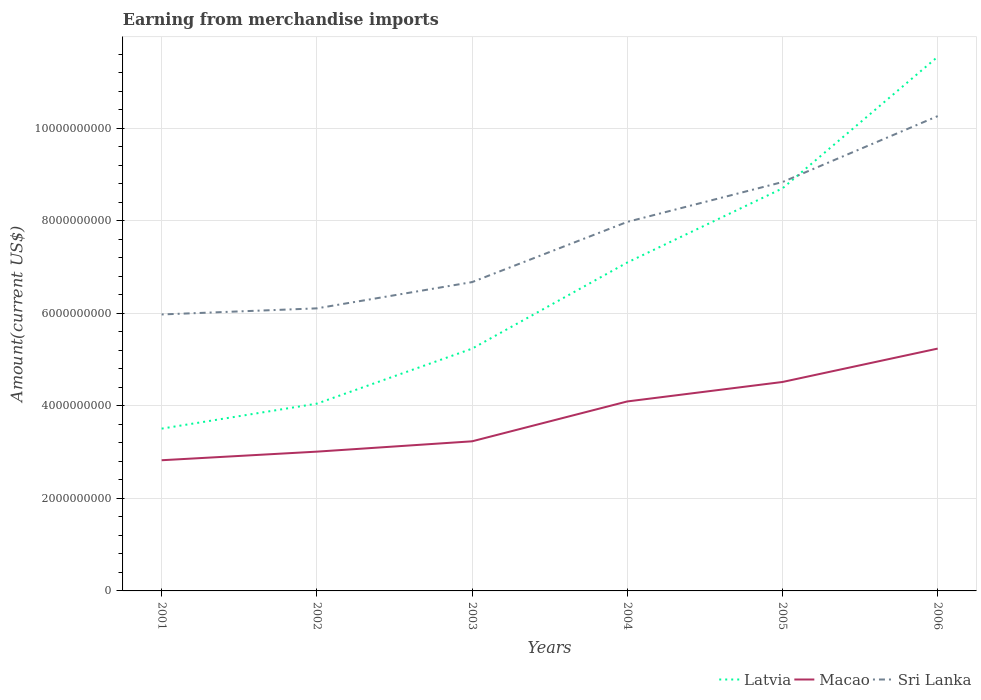Across all years, what is the maximum amount earned from merchandise imports in Sri Lanka?
Give a very brief answer. 5.97e+09. In which year was the amount earned from merchandise imports in Macao maximum?
Offer a terse response. 2001. What is the total amount earned from merchandise imports in Latvia in the graph?
Provide a short and direct response. -2.84e+09. What is the difference between the highest and the second highest amount earned from merchandise imports in Sri Lanka?
Offer a very short reply. 4.29e+09. What is the difference between two consecutive major ticks on the Y-axis?
Provide a short and direct response. 2.00e+09. Where does the legend appear in the graph?
Keep it short and to the point. Bottom right. What is the title of the graph?
Your answer should be very brief. Earning from merchandise imports. What is the label or title of the Y-axis?
Make the answer very short. Amount(current US$). What is the Amount(current US$) of Latvia in 2001?
Keep it short and to the point. 3.51e+09. What is the Amount(current US$) of Macao in 2001?
Offer a very short reply. 2.82e+09. What is the Amount(current US$) in Sri Lanka in 2001?
Ensure brevity in your answer.  5.97e+09. What is the Amount(current US$) of Latvia in 2002?
Offer a very short reply. 4.05e+09. What is the Amount(current US$) in Macao in 2002?
Your response must be concise. 3.01e+09. What is the Amount(current US$) of Sri Lanka in 2002?
Your answer should be compact. 6.10e+09. What is the Amount(current US$) in Latvia in 2003?
Provide a short and direct response. 5.23e+09. What is the Amount(current US$) in Macao in 2003?
Make the answer very short. 3.23e+09. What is the Amount(current US$) of Sri Lanka in 2003?
Your answer should be very brief. 6.67e+09. What is the Amount(current US$) in Latvia in 2004?
Offer a terse response. 7.10e+09. What is the Amount(current US$) of Macao in 2004?
Offer a terse response. 4.09e+09. What is the Amount(current US$) of Sri Lanka in 2004?
Provide a short and direct response. 7.97e+09. What is the Amount(current US$) of Latvia in 2005?
Your answer should be very brief. 8.70e+09. What is the Amount(current US$) in Macao in 2005?
Ensure brevity in your answer.  4.51e+09. What is the Amount(current US$) of Sri Lanka in 2005?
Your answer should be very brief. 8.83e+09. What is the Amount(current US$) in Latvia in 2006?
Your response must be concise. 1.15e+1. What is the Amount(current US$) of Macao in 2006?
Provide a short and direct response. 5.24e+09. What is the Amount(current US$) of Sri Lanka in 2006?
Keep it short and to the point. 1.03e+1. Across all years, what is the maximum Amount(current US$) in Latvia?
Your response must be concise. 1.15e+1. Across all years, what is the maximum Amount(current US$) of Macao?
Make the answer very short. 5.24e+09. Across all years, what is the maximum Amount(current US$) in Sri Lanka?
Your response must be concise. 1.03e+1. Across all years, what is the minimum Amount(current US$) of Latvia?
Provide a short and direct response. 3.51e+09. Across all years, what is the minimum Amount(current US$) of Macao?
Your response must be concise. 2.82e+09. Across all years, what is the minimum Amount(current US$) in Sri Lanka?
Your answer should be very brief. 5.97e+09. What is the total Amount(current US$) in Latvia in the graph?
Your response must be concise. 4.01e+1. What is the total Amount(current US$) in Macao in the graph?
Offer a terse response. 2.29e+1. What is the total Amount(current US$) in Sri Lanka in the graph?
Offer a very short reply. 4.58e+1. What is the difference between the Amount(current US$) of Latvia in 2001 and that in 2002?
Your answer should be compact. -5.40e+08. What is the difference between the Amount(current US$) in Macao in 2001 and that in 2002?
Give a very brief answer. -1.86e+08. What is the difference between the Amount(current US$) in Sri Lanka in 2001 and that in 2002?
Provide a short and direct response. -1.32e+08. What is the difference between the Amount(current US$) of Latvia in 2001 and that in 2003?
Provide a short and direct response. -1.73e+09. What is the difference between the Amount(current US$) of Macao in 2001 and that in 2003?
Your answer should be very brief. -4.09e+08. What is the difference between the Amount(current US$) in Sri Lanka in 2001 and that in 2003?
Offer a terse response. -6.99e+08. What is the difference between the Amount(current US$) of Latvia in 2001 and that in 2004?
Offer a very short reply. -3.59e+09. What is the difference between the Amount(current US$) in Macao in 2001 and that in 2004?
Your answer should be very brief. -1.27e+09. What is the difference between the Amount(current US$) of Sri Lanka in 2001 and that in 2004?
Provide a short and direct response. -2.00e+09. What is the difference between the Amount(current US$) of Latvia in 2001 and that in 2005?
Your answer should be compact. -5.19e+09. What is the difference between the Amount(current US$) in Macao in 2001 and that in 2005?
Give a very brief answer. -1.69e+09. What is the difference between the Amount(current US$) of Sri Lanka in 2001 and that in 2005?
Your answer should be very brief. -2.86e+09. What is the difference between the Amount(current US$) in Latvia in 2001 and that in 2006?
Your response must be concise. -8.03e+09. What is the difference between the Amount(current US$) in Macao in 2001 and that in 2006?
Your response must be concise. -2.41e+09. What is the difference between the Amount(current US$) of Sri Lanka in 2001 and that in 2006?
Make the answer very short. -4.29e+09. What is the difference between the Amount(current US$) in Latvia in 2002 and that in 2003?
Give a very brief answer. -1.19e+09. What is the difference between the Amount(current US$) in Macao in 2002 and that in 2003?
Your response must be concise. -2.23e+08. What is the difference between the Amount(current US$) in Sri Lanka in 2002 and that in 2003?
Your answer should be very brief. -5.67e+08. What is the difference between the Amount(current US$) of Latvia in 2002 and that in 2004?
Provide a succinct answer. -3.05e+09. What is the difference between the Amount(current US$) in Macao in 2002 and that in 2004?
Offer a very short reply. -1.08e+09. What is the difference between the Amount(current US$) of Sri Lanka in 2002 and that in 2004?
Offer a very short reply. -1.87e+09. What is the difference between the Amount(current US$) in Latvia in 2002 and that in 2005?
Your response must be concise. -4.65e+09. What is the difference between the Amount(current US$) of Macao in 2002 and that in 2005?
Offer a terse response. -1.51e+09. What is the difference between the Amount(current US$) in Sri Lanka in 2002 and that in 2005?
Ensure brevity in your answer.  -2.73e+09. What is the difference between the Amount(current US$) in Latvia in 2002 and that in 2006?
Offer a terse response. -7.49e+09. What is the difference between the Amount(current US$) in Macao in 2002 and that in 2006?
Offer a terse response. -2.23e+09. What is the difference between the Amount(current US$) of Sri Lanka in 2002 and that in 2006?
Offer a very short reply. -4.15e+09. What is the difference between the Amount(current US$) in Latvia in 2003 and that in 2004?
Provide a short and direct response. -1.86e+09. What is the difference between the Amount(current US$) in Macao in 2003 and that in 2004?
Make the answer very short. -8.61e+08. What is the difference between the Amount(current US$) of Sri Lanka in 2003 and that in 2004?
Your response must be concise. -1.30e+09. What is the difference between the Amount(current US$) in Latvia in 2003 and that in 2005?
Ensure brevity in your answer.  -3.46e+09. What is the difference between the Amount(current US$) of Macao in 2003 and that in 2005?
Your response must be concise. -1.28e+09. What is the difference between the Amount(current US$) in Sri Lanka in 2003 and that in 2005?
Provide a short and direct response. -2.16e+09. What is the difference between the Amount(current US$) of Latvia in 2003 and that in 2006?
Keep it short and to the point. -6.31e+09. What is the difference between the Amount(current US$) in Macao in 2003 and that in 2006?
Your response must be concise. -2.00e+09. What is the difference between the Amount(current US$) of Sri Lanka in 2003 and that in 2006?
Your answer should be very brief. -3.59e+09. What is the difference between the Amount(current US$) in Latvia in 2004 and that in 2005?
Your response must be concise. -1.60e+09. What is the difference between the Amount(current US$) of Macao in 2004 and that in 2005?
Offer a terse response. -4.21e+08. What is the difference between the Amount(current US$) in Sri Lanka in 2004 and that in 2005?
Make the answer very short. -8.61e+08. What is the difference between the Amount(current US$) of Latvia in 2004 and that in 2006?
Give a very brief answer. -4.45e+09. What is the difference between the Amount(current US$) of Macao in 2004 and that in 2006?
Your response must be concise. -1.14e+09. What is the difference between the Amount(current US$) in Sri Lanka in 2004 and that in 2006?
Make the answer very short. -2.29e+09. What is the difference between the Amount(current US$) of Latvia in 2005 and that in 2006?
Give a very brief answer. -2.84e+09. What is the difference between the Amount(current US$) in Macao in 2005 and that in 2006?
Provide a short and direct response. -7.21e+08. What is the difference between the Amount(current US$) in Sri Lanka in 2005 and that in 2006?
Provide a short and direct response. -1.42e+09. What is the difference between the Amount(current US$) of Latvia in 2001 and the Amount(current US$) of Macao in 2002?
Make the answer very short. 4.97e+08. What is the difference between the Amount(current US$) in Latvia in 2001 and the Amount(current US$) in Sri Lanka in 2002?
Offer a terse response. -2.60e+09. What is the difference between the Amount(current US$) in Macao in 2001 and the Amount(current US$) in Sri Lanka in 2002?
Your answer should be very brief. -3.28e+09. What is the difference between the Amount(current US$) in Latvia in 2001 and the Amount(current US$) in Macao in 2003?
Your response must be concise. 2.74e+08. What is the difference between the Amount(current US$) in Latvia in 2001 and the Amount(current US$) in Sri Lanka in 2003?
Provide a short and direct response. -3.17e+09. What is the difference between the Amount(current US$) of Macao in 2001 and the Amount(current US$) of Sri Lanka in 2003?
Keep it short and to the point. -3.85e+09. What is the difference between the Amount(current US$) of Latvia in 2001 and the Amount(current US$) of Macao in 2004?
Give a very brief answer. -5.88e+08. What is the difference between the Amount(current US$) of Latvia in 2001 and the Amount(current US$) of Sri Lanka in 2004?
Provide a short and direct response. -4.47e+09. What is the difference between the Amount(current US$) in Macao in 2001 and the Amount(current US$) in Sri Lanka in 2004?
Keep it short and to the point. -5.15e+09. What is the difference between the Amount(current US$) in Latvia in 2001 and the Amount(current US$) in Macao in 2005?
Your answer should be compact. -1.01e+09. What is the difference between the Amount(current US$) in Latvia in 2001 and the Amount(current US$) in Sri Lanka in 2005?
Your answer should be compact. -5.33e+09. What is the difference between the Amount(current US$) in Macao in 2001 and the Amount(current US$) in Sri Lanka in 2005?
Give a very brief answer. -6.01e+09. What is the difference between the Amount(current US$) in Latvia in 2001 and the Amount(current US$) in Macao in 2006?
Your response must be concise. -1.73e+09. What is the difference between the Amount(current US$) of Latvia in 2001 and the Amount(current US$) of Sri Lanka in 2006?
Your response must be concise. -6.75e+09. What is the difference between the Amount(current US$) in Macao in 2001 and the Amount(current US$) in Sri Lanka in 2006?
Provide a short and direct response. -7.43e+09. What is the difference between the Amount(current US$) of Latvia in 2002 and the Amount(current US$) of Macao in 2003?
Your answer should be very brief. 8.14e+08. What is the difference between the Amount(current US$) of Latvia in 2002 and the Amount(current US$) of Sri Lanka in 2003?
Your answer should be compact. -2.63e+09. What is the difference between the Amount(current US$) in Macao in 2002 and the Amount(current US$) in Sri Lanka in 2003?
Keep it short and to the point. -3.66e+09. What is the difference between the Amount(current US$) in Latvia in 2002 and the Amount(current US$) in Macao in 2004?
Offer a terse response. -4.77e+07. What is the difference between the Amount(current US$) in Latvia in 2002 and the Amount(current US$) in Sri Lanka in 2004?
Your response must be concise. -3.93e+09. What is the difference between the Amount(current US$) of Macao in 2002 and the Amount(current US$) of Sri Lanka in 2004?
Offer a terse response. -4.96e+09. What is the difference between the Amount(current US$) in Latvia in 2002 and the Amount(current US$) in Macao in 2005?
Offer a terse response. -4.68e+08. What is the difference between the Amount(current US$) in Latvia in 2002 and the Amount(current US$) in Sri Lanka in 2005?
Make the answer very short. -4.79e+09. What is the difference between the Amount(current US$) in Macao in 2002 and the Amount(current US$) in Sri Lanka in 2005?
Your answer should be compact. -5.82e+09. What is the difference between the Amount(current US$) in Latvia in 2002 and the Amount(current US$) in Macao in 2006?
Your answer should be compact. -1.19e+09. What is the difference between the Amount(current US$) of Latvia in 2002 and the Amount(current US$) of Sri Lanka in 2006?
Make the answer very short. -6.21e+09. What is the difference between the Amount(current US$) of Macao in 2002 and the Amount(current US$) of Sri Lanka in 2006?
Offer a terse response. -7.25e+09. What is the difference between the Amount(current US$) in Latvia in 2003 and the Amount(current US$) in Macao in 2004?
Provide a succinct answer. 1.14e+09. What is the difference between the Amount(current US$) of Latvia in 2003 and the Amount(current US$) of Sri Lanka in 2004?
Ensure brevity in your answer.  -2.74e+09. What is the difference between the Amount(current US$) of Macao in 2003 and the Amount(current US$) of Sri Lanka in 2004?
Offer a terse response. -4.74e+09. What is the difference between the Amount(current US$) of Latvia in 2003 and the Amount(current US$) of Macao in 2005?
Your answer should be very brief. 7.20e+08. What is the difference between the Amount(current US$) in Latvia in 2003 and the Amount(current US$) in Sri Lanka in 2005?
Provide a short and direct response. -3.60e+09. What is the difference between the Amount(current US$) of Macao in 2003 and the Amount(current US$) of Sri Lanka in 2005?
Make the answer very short. -5.60e+09. What is the difference between the Amount(current US$) of Latvia in 2003 and the Amount(current US$) of Macao in 2006?
Make the answer very short. -1.43e+06. What is the difference between the Amount(current US$) in Latvia in 2003 and the Amount(current US$) in Sri Lanka in 2006?
Your answer should be very brief. -5.02e+09. What is the difference between the Amount(current US$) in Macao in 2003 and the Amount(current US$) in Sri Lanka in 2006?
Your answer should be very brief. -7.03e+09. What is the difference between the Amount(current US$) of Latvia in 2004 and the Amount(current US$) of Macao in 2005?
Provide a succinct answer. 2.58e+09. What is the difference between the Amount(current US$) in Latvia in 2004 and the Amount(current US$) in Sri Lanka in 2005?
Give a very brief answer. -1.74e+09. What is the difference between the Amount(current US$) in Macao in 2004 and the Amount(current US$) in Sri Lanka in 2005?
Your answer should be very brief. -4.74e+09. What is the difference between the Amount(current US$) in Latvia in 2004 and the Amount(current US$) in Macao in 2006?
Your answer should be compact. 1.86e+09. What is the difference between the Amount(current US$) of Latvia in 2004 and the Amount(current US$) of Sri Lanka in 2006?
Provide a short and direct response. -3.16e+09. What is the difference between the Amount(current US$) in Macao in 2004 and the Amount(current US$) in Sri Lanka in 2006?
Provide a succinct answer. -6.16e+09. What is the difference between the Amount(current US$) of Latvia in 2005 and the Amount(current US$) of Macao in 2006?
Ensure brevity in your answer.  3.46e+09. What is the difference between the Amount(current US$) of Latvia in 2005 and the Amount(current US$) of Sri Lanka in 2006?
Offer a terse response. -1.56e+09. What is the difference between the Amount(current US$) of Macao in 2005 and the Amount(current US$) of Sri Lanka in 2006?
Ensure brevity in your answer.  -5.74e+09. What is the average Amount(current US$) in Latvia per year?
Make the answer very short. 6.69e+09. What is the average Amount(current US$) of Macao per year?
Give a very brief answer. 3.82e+09. What is the average Amount(current US$) of Sri Lanka per year?
Your answer should be very brief. 7.64e+09. In the year 2001, what is the difference between the Amount(current US$) in Latvia and Amount(current US$) in Macao?
Keep it short and to the point. 6.83e+08. In the year 2001, what is the difference between the Amount(current US$) of Latvia and Amount(current US$) of Sri Lanka?
Your answer should be compact. -2.47e+09. In the year 2001, what is the difference between the Amount(current US$) in Macao and Amount(current US$) in Sri Lanka?
Your answer should be very brief. -3.15e+09. In the year 2002, what is the difference between the Amount(current US$) in Latvia and Amount(current US$) in Macao?
Offer a terse response. 1.04e+09. In the year 2002, what is the difference between the Amount(current US$) in Latvia and Amount(current US$) in Sri Lanka?
Your answer should be compact. -2.06e+09. In the year 2002, what is the difference between the Amount(current US$) in Macao and Amount(current US$) in Sri Lanka?
Ensure brevity in your answer.  -3.10e+09. In the year 2003, what is the difference between the Amount(current US$) in Latvia and Amount(current US$) in Macao?
Ensure brevity in your answer.  2.00e+09. In the year 2003, what is the difference between the Amount(current US$) in Latvia and Amount(current US$) in Sri Lanka?
Provide a succinct answer. -1.44e+09. In the year 2003, what is the difference between the Amount(current US$) in Macao and Amount(current US$) in Sri Lanka?
Offer a terse response. -3.44e+09. In the year 2004, what is the difference between the Amount(current US$) of Latvia and Amount(current US$) of Macao?
Ensure brevity in your answer.  3.00e+09. In the year 2004, what is the difference between the Amount(current US$) in Latvia and Amount(current US$) in Sri Lanka?
Offer a very short reply. -8.77e+08. In the year 2004, what is the difference between the Amount(current US$) in Macao and Amount(current US$) in Sri Lanka?
Offer a very short reply. -3.88e+09. In the year 2005, what is the difference between the Amount(current US$) in Latvia and Amount(current US$) in Macao?
Give a very brief answer. 4.18e+09. In the year 2005, what is the difference between the Amount(current US$) of Latvia and Amount(current US$) of Sri Lanka?
Offer a terse response. -1.37e+08. In the year 2005, what is the difference between the Amount(current US$) of Macao and Amount(current US$) of Sri Lanka?
Offer a very short reply. -4.32e+09. In the year 2006, what is the difference between the Amount(current US$) in Latvia and Amount(current US$) in Macao?
Give a very brief answer. 6.31e+09. In the year 2006, what is the difference between the Amount(current US$) of Latvia and Amount(current US$) of Sri Lanka?
Your answer should be compact. 1.28e+09. In the year 2006, what is the difference between the Amount(current US$) of Macao and Amount(current US$) of Sri Lanka?
Your answer should be compact. -5.02e+09. What is the ratio of the Amount(current US$) in Latvia in 2001 to that in 2002?
Your answer should be very brief. 0.87. What is the ratio of the Amount(current US$) in Macao in 2001 to that in 2002?
Provide a succinct answer. 0.94. What is the ratio of the Amount(current US$) of Sri Lanka in 2001 to that in 2002?
Offer a very short reply. 0.98. What is the ratio of the Amount(current US$) of Latvia in 2001 to that in 2003?
Offer a terse response. 0.67. What is the ratio of the Amount(current US$) in Macao in 2001 to that in 2003?
Your answer should be very brief. 0.87. What is the ratio of the Amount(current US$) in Sri Lanka in 2001 to that in 2003?
Give a very brief answer. 0.9. What is the ratio of the Amount(current US$) of Latvia in 2001 to that in 2004?
Offer a very short reply. 0.49. What is the ratio of the Amount(current US$) of Macao in 2001 to that in 2004?
Ensure brevity in your answer.  0.69. What is the ratio of the Amount(current US$) in Sri Lanka in 2001 to that in 2004?
Your response must be concise. 0.75. What is the ratio of the Amount(current US$) of Latvia in 2001 to that in 2005?
Offer a very short reply. 0.4. What is the ratio of the Amount(current US$) of Macao in 2001 to that in 2005?
Ensure brevity in your answer.  0.63. What is the ratio of the Amount(current US$) in Sri Lanka in 2001 to that in 2005?
Offer a terse response. 0.68. What is the ratio of the Amount(current US$) in Latvia in 2001 to that in 2006?
Make the answer very short. 0.3. What is the ratio of the Amount(current US$) of Macao in 2001 to that in 2006?
Make the answer very short. 0.54. What is the ratio of the Amount(current US$) in Sri Lanka in 2001 to that in 2006?
Give a very brief answer. 0.58. What is the ratio of the Amount(current US$) in Latvia in 2002 to that in 2003?
Make the answer very short. 0.77. What is the ratio of the Amount(current US$) of Macao in 2002 to that in 2003?
Your response must be concise. 0.93. What is the ratio of the Amount(current US$) of Sri Lanka in 2002 to that in 2003?
Your answer should be compact. 0.92. What is the ratio of the Amount(current US$) of Latvia in 2002 to that in 2004?
Your answer should be compact. 0.57. What is the ratio of the Amount(current US$) in Macao in 2002 to that in 2004?
Offer a terse response. 0.74. What is the ratio of the Amount(current US$) of Sri Lanka in 2002 to that in 2004?
Make the answer very short. 0.77. What is the ratio of the Amount(current US$) in Latvia in 2002 to that in 2005?
Your response must be concise. 0.47. What is the ratio of the Amount(current US$) in Macao in 2002 to that in 2005?
Your response must be concise. 0.67. What is the ratio of the Amount(current US$) in Sri Lanka in 2002 to that in 2005?
Make the answer very short. 0.69. What is the ratio of the Amount(current US$) in Latvia in 2002 to that in 2006?
Keep it short and to the point. 0.35. What is the ratio of the Amount(current US$) in Macao in 2002 to that in 2006?
Provide a succinct answer. 0.57. What is the ratio of the Amount(current US$) in Sri Lanka in 2002 to that in 2006?
Your answer should be very brief. 0.6. What is the ratio of the Amount(current US$) in Latvia in 2003 to that in 2004?
Provide a short and direct response. 0.74. What is the ratio of the Amount(current US$) in Macao in 2003 to that in 2004?
Provide a succinct answer. 0.79. What is the ratio of the Amount(current US$) of Sri Lanka in 2003 to that in 2004?
Make the answer very short. 0.84. What is the ratio of the Amount(current US$) of Latvia in 2003 to that in 2005?
Your answer should be very brief. 0.6. What is the ratio of the Amount(current US$) of Macao in 2003 to that in 2005?
Ensure brevity in your answer.  0.72. What is the ratio of the Amount(current US$) in Sri Lanka in 2003 to that in 2005?
Offer a very short reply. 0.76. What is the ratio of the Amount(current US$) of Latvia in 2003 to that in 2006?
Provide a short and direct response. 0.45. What is the ratio of the Amount(current US$) of Macao in 2003 to that in 2006?
Your response must be concise. 0.62. What is the ratio of the Amount(current US$) of Sri Lanka in 2003 to that in 2006?
Ensure brevity in your answer.  0.65. What is the ratio of the Amount(current US$) in Latvia in 2004 to that in 2005?
Make the answer very short. 0.82. What is the ratio of the Amount(current US$) of Macao in 2004 to that in 2005?
Ensure brevity in your answer.  0.91. What is the ratio of the Amount(current US$) in Sri Lanka in 2004 to that in 2005?
Your answer should be very brief. 0.9. What is the ratio of the Amount(current US$) in Latvia in 2004 to that in 2006?
Make the answer very short. 0.61. What is the ratio of the Amount(current US$) of Macao in 2004 to that in 2006?
Provide a succinct answer. 0.78. What is the ratio of the Amount(current US$) of Sri Lanka in 2004 to that in 2006?
Offer a terse response. 0.78. What is the ratio of the Amount(current US$) of Latvia in 2005 to that in 2006?
Provide a succinct answer. 0.75. What is the ratio of the Amount(current US$) in Macao in 2005 to that in 2006?
Offer a very short reply. 0.86. What is the ratio of the Amount(current US$) of Sri Lanka in 2005 to that in 2006?
Your response must be concise. 0.86. What is the difference between the highest and the second highest Amount(current US$) in Latvia?
Your answer should be compact. 2.84e+09. What is the difference between the highest and the second highest Amount(current US$) of Macao?
Offer a very short reply. 7.21e+08. What is the difference between the highest and the second highest Amount(current US$) of Sri Lanka?
Your answer should be compact. 1.42e+09. What is the difference between the highest and the lowest Amount(current US$) in Latvia?
Make the answer very short. 8.03e+09. What is the difference between the highest and the lowest Amount(current US$) in Macao?
Your response must be concise. 2.41e+09. What is the difference between the highest and the lowest Amount(current US$) of Sri Lanka?
Ensure brevity in your answer.  4.29e+09. 